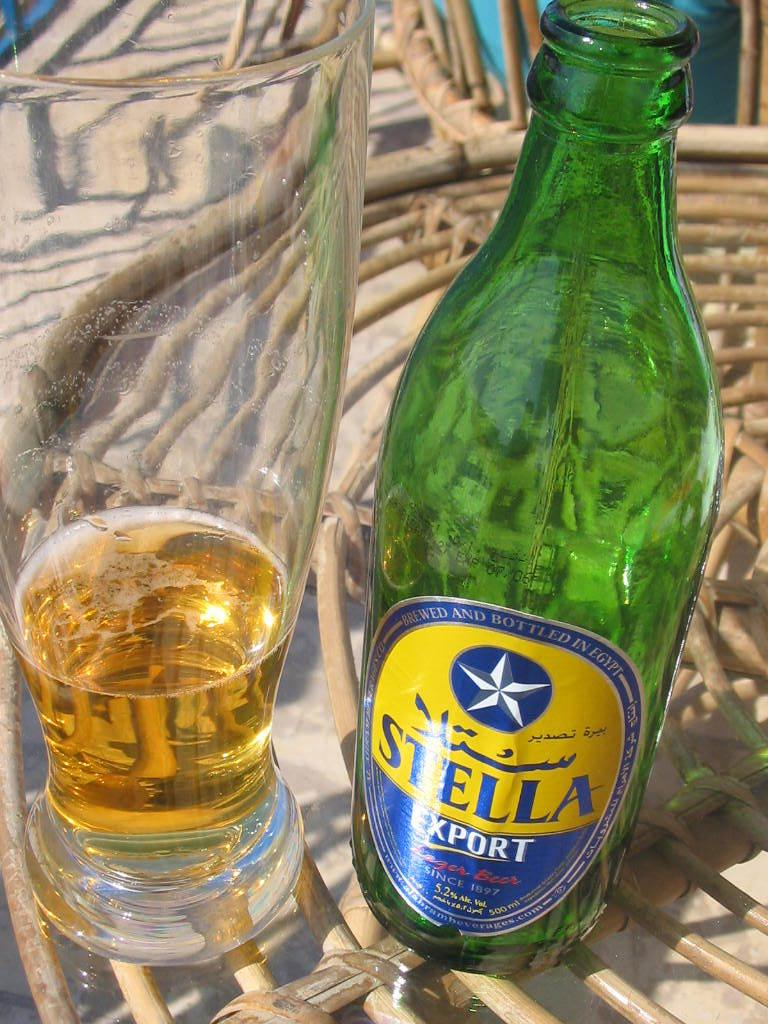<image>
Render a clear and concise summary of the photo. Stella Export fills the bottom of a glass and the empty bottle sits next to it. 